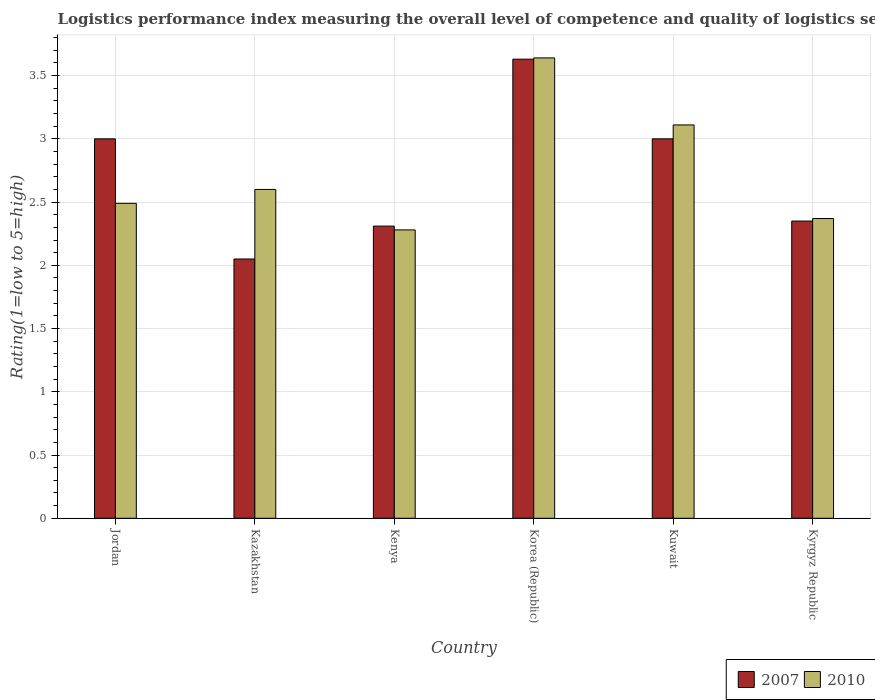How many different coloured bars are there?
Keep it short and to the point. 2. How many groups of bars are there?
Provide a short and direct response. 6. Are the number of bars per tick equal to the number of legend labels?
Keep it short and to the point. Yes. Are the number of bars on each tick of the X-axis equal?
Your answer should be compact. Yes. What is the label of the 6th group of bars from the left?
Your response must be concise. Kyrgyz Republic. In how many cases, is the number of bars for a given country not equal to the number of legend labels?
Offer a very short reply. 0. What is the Logistic performance index in 2010 in Kuwait?
Offer a terse response. 3.11. Across all countries, what is the maximum Logistic performance index in 2007?
Ensure brevity in your answer.  3.63. Across all countries, what is the minimum Logistic performance index in 2010?
Keep it short and to the point. 2.28. In which country was the Logistic performance index in 2010 maximum?
Provide a short and direct response. Korea (Republic). In which country was the Logistic performance index in 2010 minimum?
Make the answer very short. Kenya. What is the total Logistic performance index in 2010 in the graph?
Your answer should be compact. 16.49. What is the difference between the Logistic performance index in 2007 in Jordan and that in Kazakhstan?
Offer a very short reply. 0.95. What is the difference between the Logistic performance index in 2007 in Kenya and the Logistic performance index in 2010 in Kazakhstan?
Give a very brief answer. -0.29. What is the average Logistic performance index in 2007 per country?
Your answer should be compact. 2.72. What is the difference between the Logistic performance index of/in 2010 and Logistic performance index of/in 2007 in Kuwait?
Offer a terse response. 0.11. In how many countries, is the Logistic performance index in 2010 greater than 1.6?
Your answer should be very brief. 6. What is the ratio of the Logistic performance index in 2007 in Korea (Republic) to that in Kuwait?
Your answer should be compact. 1.21. Is the Logistic performance index in 2010 in Kazakhstan less than that in Kenya?
Keep it short and to the point. No. Is the difference between the Logistic performance index in 2010 in Jordan and Kazakhstan greater than the difference between the Logistic performance index in 2007 in Jordan and Kazakhstan?
Ensure brevity in your answer.  No. What is the difference between the highest and the second highest Logistic performance index in 2010?
Your response must be concise. 0.51. What is the difference between the highest and the lowest Logistic performance index in 2007?
Provide a succinct answer. 1.58. In how many countries, is the Logistic performance index in 2007 greater than the average Logistic performance index in 2007 taken over all countries?
Provide a short and direct response. 3. Is the sum of the Logistic performance index in 2007 in Kazakhstan and Kenya greater than the maximum Logistic performance index in 2010 across all countries?
Keep it short and to the point. Yes. What does the 1st bar from the left in Kyrgyz Republic represents?
Give a very brief answer. 2007. What does the 2nd bar from the right in Kazakhstan represents?
Give a very brief answer. 2007. How many bars are there?
Your answer should be compact. 12. Are all the bars in the graph horizontal?
Provide a short and direct response. No. What is the difference between two consecutive major ticks on the Y-axis?
Your answer should be compact. 0.5. Does the graph contain any zero values?
Your response must be concise. No. How are the legend labels stacked?
Provide a succinct answer. Horizontal. What is the title of the graph?
Offer a terse response. Logistics performance index measuring the overall level of competence and quality of logistics services. Does "2004" appear as one of the legend labels in the graph?
Keep it short and to the point. No. What is the label or title of the X-axis?
Make the answer very short. Country. What is the label or title of the Y-axis?
Give a very brief answer. Rating(1=low to 5=high). What is the Rating(1=low to 5=high) of 2010 in Jordan?
Keep it short and to the point. 2.49. What is the Rating(1=low to 5=high) of 2007 in Kazakhstan?
Your response must be concise. 2.05. What is the Rating(1=low to 5=high) in 2010 in Kazakhstan?
Provide a short and direct response. 2.6. What is the Rating(1=low to 5=high) in 2007 in Kenya?
Your answer should be very brief. 2.31. What is the Rating(1=low to 5=high) in 2010 in Kenya?
Provide a short and direct response. 2.28. What is the Rating(1=low to 5=high) of 2007 in Korea (Republic)?
Keep it short and to the point. 3.63. What is the Rating(1=low to 5=high) of 2010 in Korea (Republic)?
Keep it short and to the point. 3.64. What is the Rating(1=low to 5=high) of 2010 in Kuwait?
Provide a succinct answer. 3.11. What is the Rating(1=low to 5=high) of 2007 in Kyrgyz Republic?
Keep it short and to the point. 2.35. What is the Rating(1=low to 5=high) in 2010 in Kyrgyz Republic?
Ensure brevity in your answer.  2.37. Across all countries, what is the maximum Rating(1=low to 5=high) in 2007?
Your answer should be compact. 3.63. Across all countries, what is the maximum Rating(1=low to 5=high) of 2010?
Keep it short and to the point. 3.64. Across all countries, what is the minimum Rating(1=low to 5=high) in 2007?
Your answer should be very brief. 2.05. Across all countries, what is the minimum Rating(1=low to 5=high) of 2010?
Your response must be concise. 2.28. What is the total Rating(1=low to 5=high) of 2007 in the graph?
Keep it short and to the point. 16.34. What is the total Rating(1=low to 5=high) of 2010 in the graph?
Your response must be concise. 16.49. What is the difference between the Rating(1=low to 5=high) of 2007 in Jordan and that in Kazakhstan?
Keep it short and to the point. 0.95. What is the difference between the Rating(1=low to 5=high) of 2010 in Jordan and that in Kazakhstan?
Provide a succinct answer. -0.11. What is the difference between the Rating(1=low to 5=high) of 2007 in Jordan and that in Kenya?
Your response must be concise. 0.69. What is the difference between the Rating(1=low to 5=high) of 2010 in Jordan and that in Kenya?
Keep it short and to the point. 0.21. What is the difference between the Rating(1=low to 5=high) in 2007 in Jordan and that in Korea (Republic)?
Give a very brief answer. -0.63. What is the difference between the Rating(1=low to 5=high) of 2010 in Jordan and that in Korea (Republic)?
Offer a terse response. -1.15. What is the difference between the Rating(1=low to 5=high) of 2010 in Jordan and that in Kuwait?
Give a very brief answer. -0.62. What is the difference between the Rating(1=low to 5=high) of 2007 in Jordan and that in Kyrgyz Republic?
Provide a short and direct response. 0.65. What is the difference between the Rating(1=low to 5=high) of 2010 in Jordan and that in Kyrgyz Republic?
Offer a terse response. 0.12. What is the difference between the Rating(1=low to 5=high) of 2007 in Kazakhstan and that in Kenya?
Make the answer very short. -0.26. What is the difference between the Rating(1=low to 5=high) of 2010 in Kazakhstan and that in Kenya?
Provide a short and direct response. 0.32. What is the difference between the Rating(1=low to 5=high) of 2007 in Kazakhstan and that in Korea (Republic)?
Offer a very short reply. -1.58. What is the difference between the Rating(1=low to 5=high) of 2010 in Kazakhstan and that in Korea (Republic)?
Provide a short and direct response. -1.04. What is the difference between the Rating(1=low to 5=high) of 2007 in Kazakhstan and that in Kuwait?
Give a very brief answer. -0.95. What is the difference between the Rating(1=low to 5=high) of 2010 in Kazakhstan and that in Kuwait?
Keep it short and to the point. -0.51. What is the difference between the Rating(1=low to 5=high) of 2010 in Kazakhstan and that in Kyrgyz Republic?
Ensure brevity in your answer.  0.23. What is the difference between the Rating(1=low to 5=high) of 2007 in Kenya and that in Korea (Republic)?
Your answer should be very brief. -1.32. What is the difference between the Rating(1=low to 5=high) in 2010 in Kenya and that in Korea (Republic)?
Provide a succinct answer. -1.36. What is the difference between the Rating(1=low to 5=high) of 2007 in Kenya and that in Kuwait?
Keep it short and to the point. -0.69. What is the difference between the Rating(1=low to 5=high) of 2010 in Kenya and that in Kuwait?
Give a very brief answer. -0.83. What is the difference between the Rating(1=low to 5=high) in 2007 in Kenya and that in Kyrgyz Republic?
Your answer should be compact. -0.04. What is the difference between the Rating(1=low to 5=high) in 2010 in Kenya and that in Kyrgyz Republic?
Your response must be concise. -0.09. What is the difference between the Rating(1=low to 5=high) in 2007 in Korea (Republic) and that in Kuwait?
Keep it short and to the point. 0.63. What is the difference between the Rating(1=low to 5=high) of 2010 in Korea (Republic) and that in Kuwait?
Ensure brevity in your answer.  0.53. What is the difference between the Rating(1=low to 5=high) of 2007 in Korea (Republic) and that in Kyrgyz Republic?
Offer a terse response. 1.28. What is the difference between the Rating(1=low to 5=high) in 2010 in Korea (Republic) and that in Kyrgyz Republic?
Offer a very short reply. 1.27. What is the difference between the Rating(1=low to 5=high) of 2007 in Kuwait and that in Kyrgyz Republic?
Keep it short and to the point. 0.65. What is the difference between the Rating(1=low to 5=high) of 2010 in Kuwait and that in Kyrgyz Republic?
Your answer should be compact. 0.74. What is the difference between the Rating(1=low to 5=high) of 2007 in Jordan and the Rating(1=low to 5=high) of 2010 in Kenya?
Your answer should be compact. 0.72. What is the difference between the Rating(1=low to 5=high) in 2007 in Jordan and the Rating(1=low to 5=high) in 2010 in Korea (Republic)?
Offer a very short reply. -0.64. What is the difference between the Rating(1=low to 5=high) of 2007 in Jordan and the Rating(1=low to 5=high) of 2010 in Kuwait?
Provide a succinct answer. -0.11. What is the difference between the Rating(1=low to 5=high) of 2007 in Jordan and the Rating(1=low to 5=high) of 2010 in Kyrgyz Republic?
Give a very brief answer. 0.63. What is the difference between the Rating(1=low to 5=high) of 2007 in Kazakhstan and the Rating(1=low to 5=high) of 2010 in Kenya?
Offer a very short reply. -0.23. What is the difference between the Rating(1=low to 5=high) in 2007 in Kazakhstan and the Rating(1=low to 5=high) in 2010 in Korea (Republic)?
Offer a terse response. -1.59. What is the difference between the Rating(1=low to 5=high) in 2007 in Kazakhstan and the Rating(1=low to 5=high) in 2010 in Kuwait?
Give a very brief answer. -1.06. What is the difference between the Rating(1=low to 5=high) of 2007 in Kazakhstan and the Rating(1=low to 5=high) of 2010 in Kyrgyz Republic?
Offer a terse response. -0.32. What is the difference between the Rating(1=low to 5=high) of 2007 in Kenya and the Rating(1=low to 5=high) of 2010 in Korea (Republic)?
Your response must be concise. -1.33. What is the difference between the Rating(1=low to 5=high) of 2007 in Kenya and the Rating(1=low to 5=high) of 2010 in Kyrgyz Republic?
Offer a terse response. -0.06. What is the difference between the Rating(1=low to 5=high) of 2007 in Korea (Republic) and the Rating(1=low to 5=high) of 2010 in Kuwait?
Keep it short and to the point. 0.52. What is the difference between the Rating(1=low to 5=high) in 2007 in Korea (Republic) and the Rating(1=low to 5=high) in 2010 in Kyrgyz Republic?
Give a very brief answer. 1.26. What is the difference between the Rating(1=low to 5=high) of 2007 in Kuwait and the Rating(1=low to 5=high) of 2010 in Kyrgyz Republic?
Ensure brevity in your answer.  0.63. What is the average Rating(1=low to 5=high) in 2007 per country?
Your answer should be compact. 2.72. What is the average Rating(1=low to 5=high) of 2010 per country?
Your answer should be very brief. 2.75. What is the difference between the Rating(1=low to 5=high) of 2007 and Rating(1=low to 5=high) of 2010 in Jordan?
Your response must be concise. 0.51. What is the difference between the Rating(1=low to 5=high) of 2007 and Rating(1=low to 5=high) of 2010 in Kazakhstan?
Provide a short and direct response. -0.55. What is the difference between the Rating(1=low to 5=high) in 2007 and Rating(1=low to 5=high) in 2010 in Kenya?
Your answer should be compact. 0.03. What is the difference between the Rating(1=low to 5=high) in 2007 and Rating(1=low to 5=high) in 2010 in Korea (Republic)?
Provide a short and direct response. -0.01. What is the difference between the Rating(1=low to 5=high) of 2007 and Rating(1=low to 5=high) of 2010 in Kuwait?
Your response must be concise. -0.11. What is the difference between the Rating(1=low to 5=high) of 2007 and Rating(1=low to 5=high) of 2010 in Kyrgyz Republic?
Your answer should be very brief. -0.02. What is the ratio of the Rating(1=low to 5=high) of 2007 in Jordan to that in Kazakhstan?
Make the answer very short. 1.46. What is the ratio of the Rating(1=low to 5=high) of 2010 in Jordan to that in Kazakhstan?
Your response must be concise. 0.96. What is the ratio of the Rating(1=low to 5=high) in 2007 in Jordan to that in Kenya?
Ensure brevity in your answer.  1.3. What is the ratio of the Rating(1=low to 5=high) of 2010 in Jordan to that in Kenya?
Ensure brevity in your answer.  1.09. What is the ratio of the Rating(1=low to 5=high) in 2007 in Jordan to that in Korea (Republic)?
Give a very brief answer. 0.83. What is the ratio of the Rating(1=low to 5=high) of 2010 in Jordan to that in Korea (Republic)?
Give a very brief answer. 0.68. What is the ratio of the Rating(1=low to 5=high) of 2010 in Jordan to that in Kuwait?
Provide a succinct answer. 0.8. What is the ratio of the Rating(1=low to 5=high) in 2007 in Jordan to that in Kyrgyz Republic?
Provide a short and direct response. 1.28. What is the ratio of the Rating(1=low to 5=high) in 2010 in Jordan to that in Kyrgyz Republic?
Provide a short and direct response. 1.05. What is the ratio of the Rating(1=low to 5=high) in 2007 in Kazakhstan to that in Kenya?
Provide a succinct answer. 0.89. What is the ratio of the Rating(1=low to 5=high) of 2010 in Kazakhstan to that in Kenya?
Offer a terse response. 1.14. What is the ratio of the Rating(1=low to 5=high) of 2007 in Kazakhstan to that in Korea (Republic)?
Give a very brief answer. 0.56. What is the ratio of the Rating(1=low to 5=high) in 2010 in Kazakhstan to that in Korea (Republic)?
Make the answer very short. 0.71. What is the ratio of the Rating(1=low to 5=high) in 2007 in Kazakhstan to that in Kuwait?
Your answer should be very brief. 0.68. What is the ratio of the Rating(1=low to 5=high) of 2010 in Kazakhstan to that in Kuwait?
Keep it short and to the point. 0.84. What is the ratio of the Rating(1=low to 5=high) of 2007 in Kazakhstan to that in Kyrgyz Republic?
Make the answer very short. 0.87. What is the ratio of the Rating(1=low to 5=high) of 2010 in Kazakhstan to that in Kyrgyz Republic?
Give a very brief answer. 1.1. What is the ratio of the Rating(1=low to 5=high) of 2007 in Kenya to that in Korea (Republic)?
Offer a terse response. 0.64. What is the ratio of the Rating(1=low to 5=high) in 2010 in Kenya to that in Korea (Republic)?
Your answer should be compact. 0.63. What is the ratio of the Rating(1=low to 5=high) of 2007 in Kenya to that in Kuwait?
Provide a succinct answer. 0.77. What is the ratio of the Rating(1=low to 5=high) in 2010 in Kenya to that in Kuwait?
Make the answer very short. 0.73. What is the ratio of the Rating(1=low to 5=high) of 2010 in Kenya to that in Kyrgyz Republic?
Provide a succinct answer. 0.96. What is the ratio of the Rating(1=low to 5=high) in 2007 in Korea (Republic) to that in Kuwait?
Offer a very short reply. 1.21. What is the ratio of the Rating(1=low to 5=high) of 2010 in Korea (Republic) to that in Kuwait?
Ensure brevity in your answer.  1.17. What is the ratio of the Rating(1=low to 5=high) of 2007 in Korea (Republic) to that in Kyrgyz Republic?
Your answer should be compact. 1.54. What is the ratio of the Rating(1=low to 5=high) of 2010 in Korea (Republic) to that in Kyrgyz Republic?
Offer a terse response. 1.54. What is the ratio of the Rating(1=low to 5=high) in 2007 in Kuwait to that in Kyrgyz Republic?
Your response must be concise. 1.28. What is the ratio of the Rating(1=low to 5=high) in 2010 in Kuwait to that in Kyrgyz Republic?
Keep it short and to the point. 1.31. What is the difference between the highest and the second highest Rating(1=low to 5=high) of 2007?
Your answer should be compact. 0.63. What is the difference between the highest and the second highest Rating(1=low to 5=high) of 2010?
Your response must be concise. 0.53. What is the difference between the highest and the lowest Rating(1=low to 5=high) in 2007?
Give a very brief answer. 1.58. What is the difference between the highest and the lowest Rating(1=low to 5=high) of 2010?
Make the answer very short. 1.36. 